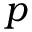Convert formula to latex. <formula><loc_0><loc_0><loc_500><loc_500>p</formula> 